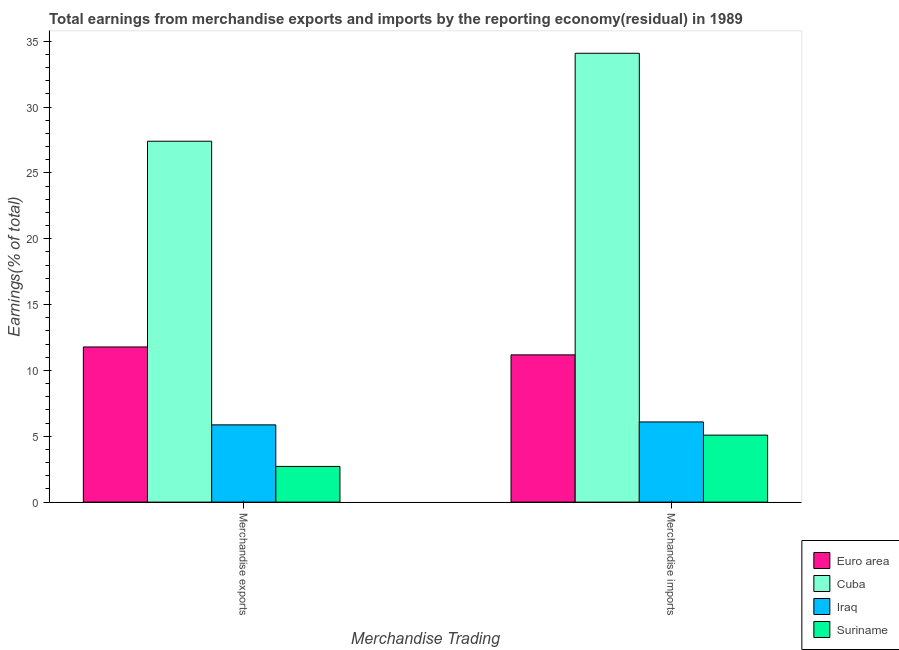How many groups of bars are there?
Your response must be concise. 2. Are the number of bars per tick equal to the number of legend labels?
Give a very brief answer. Yes. What is the label of the 2nd group of bars from the left?
Offer a terse response. Merchandise imports. What is the earnings from merchandise imports in Suriname?
Ensure brevity in your answer.  5.09. Across all countries, what is the maximum earnings from merchandise exports?
Ensure brevity in your answer.  27.4. Across all countries, what is the minimum earnings from merchandise exports?
Keep it short and to the point. 2.71. In which country was the earnings from merchandise exports maximum?
Provide a short and direct response. Cuba. In which country was the earnings from merchandise imports minimum?
Offer a very short reply. Suriname. What is the total earnings from merchandise imports in the graph?
Provide a short and direct response. 56.44. What is the difference between the earnings from merchandise imports in Suriname and that in Iraq?
Your answer should be compact. -1. What is the difference between the earnings from merchandise imports in Suriname and the earnings from merchandise exports in Cuba?
Your answer should be very brief. -22.32. What is the average earnings from merchandise imports per country?
Your response must be concise. 14.11. What is the difference between the earnings from merchandise imports and earnings from merchandise exports in Cuba?
Ensure brevity in your answer.  6.68. In how many countries, is the earnings from merchandise exports greater than 29 %?
Offer a terse response. 0. What is the ratio of the earnings from merchandise imports in Suriname to that in Euro area?
Provide a succinct answer. 0.46. What does the 2nd bar from the left in Merchandise imports represents?
Give a very brief answer. Cuba. What does the 3rd bar from the right in Merchandise exports represents?
Make the answer very short. Cuba. How many bars are there?
Make the answer very short. 8. Are all the bars in the graph horizontal?
Offer a very short reply. No. What is the difference between two consecutive major ticks on the Y-axis?
Your answer should be compact. 5. Are the values on the major ticks of Y-axis written in scientific E-notation?
Provide a succinct answer. No. Does the graph contain grids?
Your answer should be compact. No. Where does the legend appear in the graph?
Provide a short and direct response. Bottom right. How many legend labels are there?
Your answer should be compact. 4. How are the legend labels stacked?
Offer a very short reply. Vertical. What is the title of the graph?
Offer a terse response. Total earnings from merchandise exports and imports by the reporting economy(residual) in 1989. What is the label or title of the X-axis?
Provide a succinct answer. Merchandise Trading. What is the label or title of the Y-axis?
Make the answer very short. Earnings(% of total). What is the Earnings(% of total) in Euro area in Merchandise exports?
Your answer should be very brief. 11.78. What is the Earnings(% of total) of Cuba in Merchandise exports?
Provide a succinct answer. 27.4. What is the Earnings(% of total) in Iraq in Merchandise exports?
Offer a very short reply. 5.87. What is the Earnings(% of total) in Suriname in Merchandise exports?
Offer a terse response. 2.71. What is the Earnings(% of total) in Euro area in Merchandise imports?
Provide a succinct answer. 11.18. What is the Earnings(% of total) in Cuba in Merchandise imports?
Your answer should be compact. 34.08. What is the Earnings(% of total) in Iraq in Merchandise imports?
Your answer should be very brief. 6.09. What is the Earnings(% of total) in Suriname in Merchandise imports?
Offer a terse response. 5.09. Across all Merchandise Trading, what is the maximum Earnings(% of total) in Euro area?
Keep it short and to the point. 11.78. Across all Merchandise Trading, what is the maximum Earnings(% of total) in Cuba?
Your answer should be very brief. 34.08. Across all Merchandise Trading, what is the maximum Earnings(% of total) of Iraq?
Keep it short and to the point. 6.09. Across all Merchandise Trading, what is the maximum Earnings(% of total) in Suriname?
Offer a very short reply. 5.09. Across all Merchandise Trading, what is the minimum Earnings(% of total) of Euro area?
Offer a very short reply. 11.18. Across all Merchandise Trading, what is the minimum Earnings(% of total) in Cuba?
Offer a terse response. 27.4. Across all Merchandise Trading, what is the minimum Earnings(% of total) of Iraq?
Give a very brief answer. 5.87. Across all Merchandise Trading, what is the minimum Earnings(% of total) of Suriname?
Your answer should be compact. 2.71. What is the total Earnings(% of total) in Euro area in the graph?
Your response must be concise. 22.96. What is the total Earnings(% of total) of Cuba in the graph?
Offer a very short reply. 61.49. What is the total Earnings(% of total) of Iraq in the graph?
Provide a short and direct response. 11.95. What is the total Earnings(% of total) in Suriname in the graph?
Your answer should be very brief. 7.8. What is the difference between the Earnings(% of total) in Euro area in Merchandise exports and that in Merchandise imports?
Provide a succinct answer. 0.6. What is the difference between the Earnings(% of total) in Cuba in Merchandise exports and that in Merchandise imports?
Your response must be concise. -6.68. What is the difference between the Earnings(% of total) in Iraq in Merchandise exports and that in Merchandise imports?
Keep it short and to the point. -0.22. What is the difference between the Earnings(% of total) in Suriname in Merchandise exports and that in Merchandise imports?
Provide a succinct answer. -2.38. What is the difference between the Earnings(% of total) in Euro area in Merchandise exports and the Earnings(% of total) in Cuba in Merchandise imports?
Offer a terse response. -22.3. What is the difference between the Earnings(% of total) in Euro area in Merchandise exports and the Earnings(% of total) in Iraq in Merchandise imports?
Provide a short and direct response. 5.69. What is the difference between the Earnings(% of total) in Euro area in Merchandise exports and the Earnings(% of total) in Suriname in Merchandise imports?
Your answer should be compact. 6.69. What is the difference between the Earnings(% of total) in Cuba in Merchandise exports and the Earnings(% of total) in Iraq in Merchandise imports?
Your answer should be very brief. 21.32. What is the difference between the Earnings(% of total) in Cuba in Merchandise exports and the Earnings(% of total) in Suriname in Merchandise imports?
Make the answer very short. 22.32. What is the difference between the Earnings(% of total) of Iraq in Merchandise exports and the Earnings(% of total) of Suriname in Merchandise imports?
Make the answer very short. 0.78. What is the average Earnings(% of total) of Euro area per Merchandise Trading?
Make the answer very short. 11.48. What is the average Earnings(% of total) in Cuba per Merchandise Trading?
Offer a very short reply. 30.74. What is the average Earnings(% of total) of Iraq per Merchandise Trading?
Your response must be concise. 5.98. What is the average Earnings(% of total) of Suriname per Merchandise Trading?
Provide a short and direct response. 3.9. What is the difference between the Earnings(% of total) of Euro area and Earnings(% of total) of Cuba in Merchandise exports?
Ensure brevity in your answer.  -15.62. What is the difference between the Earnings(% of total) in Euro area and Earnings(% of total) in Iraq in Merchandise exports?
Give a very brief answer. 5.92. What is the difference between the Earnings(% of total) of Euro area and Earnings(% of total) of Suriname in Merchandise exports?
Your answer should be very brief. 9.07. What is the difference between the Earnings(% of total) of Cuba and Earnings(% of total) of Iraq in Merchandise exports?
Give a very brief answer. 21.54. What is the difference between the Earnings(% of total) of Cuba and Earnings(% of total) of Suriname in Merchandise exports?
Keep it short and to the point. 24.69. What is the difference between the Earnings(% of total) of Iraq and Earnings(% of total) of Suriname in Merchandise exports?
Provide a succinct answer. 3.16. What is the difference between the Earnings(% of total) in Euro area and Earnings(% of total) in Cuba in Merchandise imports?
Ensure brevity in your answer.  -22.9. What is the difference between the Earnings(% of total) in Euro area and Earnings(% of total) in Iraq in Merchandise imports?
Provide a succinct answer. 5.09. What is the difference between the Earnings(% of total) of Euro area and Earnings(% of total) of Suriname in Merchandise imports?
Your answer should be very brief. 6.09. What is the difference between the Earnings(% of total) in Cuba and Earnings(% of total) in Iraq in Merchandise imports?
Offer a very short reply. 27.99. What is the difference between the Earnings(% of total) of Cuba and Earnings(% of total) of Suriname in Merchandise imports?
Offer a terse response. 29. What is the ratio of the Earnings(% of total) in Euro area in Merchandise exports to that in Merchandise imports?
Make the answer very short. 1.05. What is the ratio of the Earnings(% of total) of Cuba in Merchandise exports to that in Merchandise imports?
Make the answer very short. 0.8. What is the ratio of the Earnings(% of total) in Iraq in Merchandise exports to that in Merchandise imports?
Keep it short and to the point. 0.96. What is the ratio of the Earnings(% of total) in Suriname in Merchandise exports to that in Merchandise imports?
Ensure brevity in your answer.  0.53. What is the difference between the highest and the second highest Earnings(% of total) in Euro area?
Ensure brevity in your answer.  0.6. What is the difference between the highest and the second highest Earnings(% of total) in Cuba?
Keep it short and to the point. 6.68. What is the difference between the highest and the second highest Earnings(% of total) of Iraq?
Offer a very short reply. 0.22. What is the difference between the highest and the second highest Earnings(% of total) in Suriname?
Offer a terse response. 2.38. What is the difference between the highest and the lowest Earnings(% of total) in Euro area?
Provide a succinct answer. 0.6. What is the difference between the highest and the lowest Earnings(% of total) in Cuba?
Offer a very short reply. 6.68. What is the difference between the highest and the lowest Earnings(% of total) in Iraq?
Offer a terse response. 0.22. What is the difference between the highest and the lowest Earnings(% of total) in Suriname?
Your answer should be compact. 2.38. 